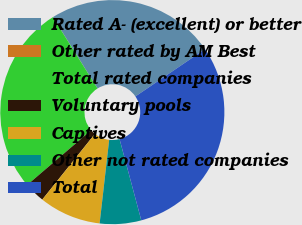Convert chart. <chart><loc_0><loc_0><loc_500><loc_500><pie_chart><fcel>Rated A- (excellent) or better<fcel>Other rated by AM Best<fcel>Total rated companies<fcel>Voluntary pools<fcel>Captives<fcel>Other not rated companies<fcel>Total<nl><fcel>24.39%<fcel>0.01%<fcel>27.36%<fcel>2.99%<fcel>8.94%<fcel>5.97%<fcel>30.34%<nl></chart> 